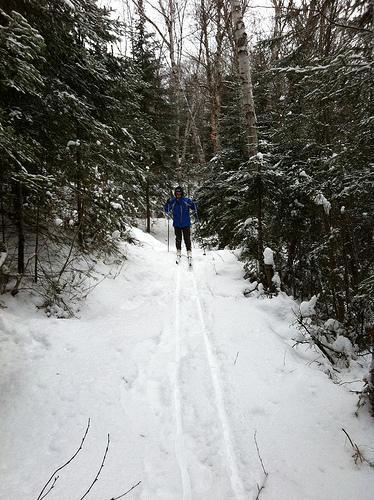How many people are there?
Give a very brief answer. 1. 